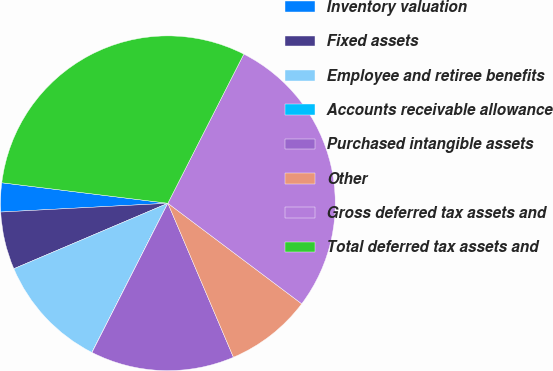<chart> <loc_0><loc_0><loc_500><loc_500><pie_chart><fcel>Inventory valuation<fcel>Fixed assets<fcel>Employee and retiree benefits<fcel>Accounts receivable allowance<fcel>Purchased intangible assets<fcel>Other<fcel>Gross deferred tax assets and<fcel>Total deferred tax assets and<nl><fcel>2.79%<fcel>5.56%<fcel>11.11%<fcel>0.01%<fcel>13.89%<fcel>8.34%<fcel>27.76%<fcel>30.54%<nl></chart> 